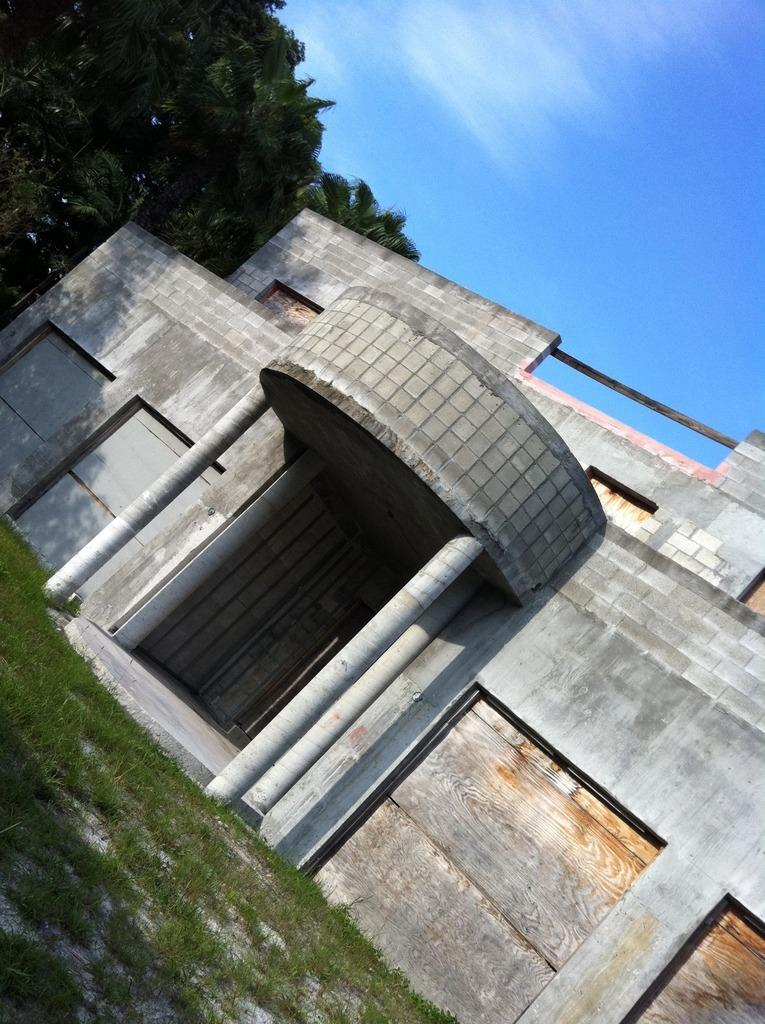What type of structure is present in the image? There is a building in the image. What type of vegetation can be seen in the image? There is grass and trees in the image. What part of the natural environment is visible in the image? The sky is visible in the background of the image. How many cars are parked on the grass in the image? There are no cars present in the image; it features a building, grass, trees, and the sky. 